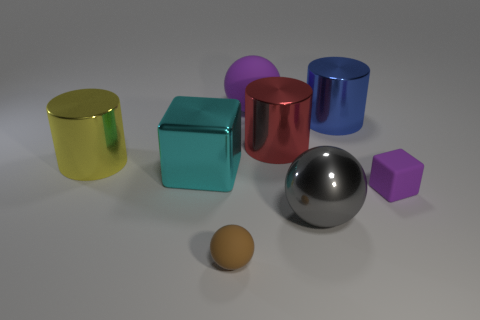There is a tiny object that is the same color as the big matte object; what material is it?
Your answer should be compact. Rubber. There is a rubber object that is behind the yellow object; is it the same color as the tiny block?
Your answer should be very brief. Yes. There is a big ball that is behind the tiny purple matte object; does it have the same color as the cube in front of the cyan metallic block?
Your answer should be compact. Yes. What number of other things are there of the same color as the big matte object?
Give a very brief answer. 1. How big is the thing that is both right of the gray shiny object and behind the red metal thing?
Provide a succinct answer. Large. The large cylinder that is left of the small matte thing that is left of the rubber cube is what color?
Your answer should be compact. Yellow. What number of big yellow metal things are there?
Offer a very short reply. 1. Does the small matte block have the same color as the big rubber object?
Offer a very short reply. Yes. Are there fewer brown spheres behind the cyan block than spheres in front of the yellow cylinder?
Keep it short and to the point. Yes. The small cube is what color?
Your answer should be very brief. Purple. 